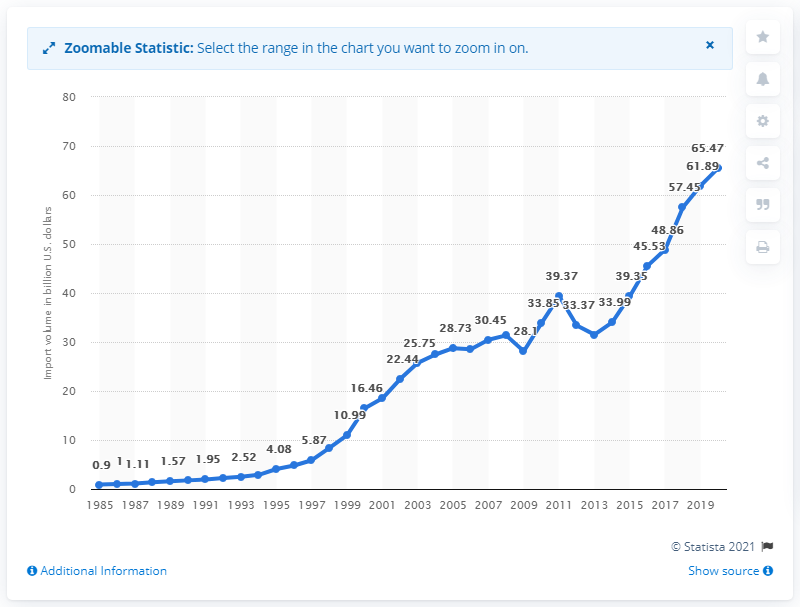List a handful of essential elements in this visual. In 2020, the value of imports from Ireland was 65.47.. 